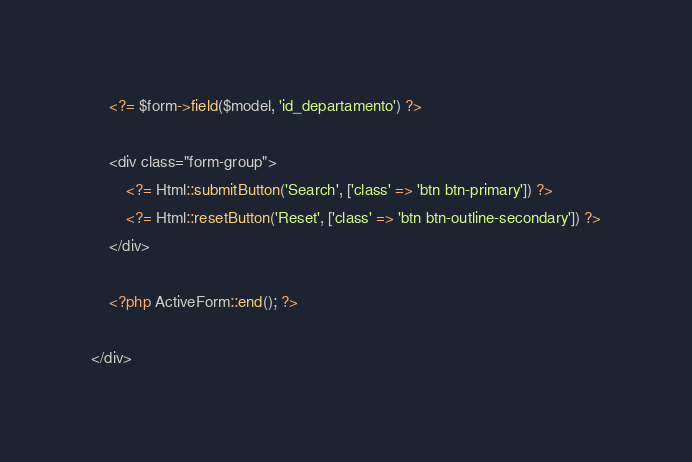<code> <loc_0><loc_0><loc_500><loc_500><_PHP_>    <?= $form->field($model, 'id_departamento') ?>

    <div class="form-group">
        <?= Html::submitButton('Search', ['class' => 'btn btn-primary']) ?>
        <?= Html::resetButton('Reset', ['class' => 'btn btn-outline-secondary']) ?>
    </div>

    <?php ActiveForm::end(); ?>

</div>
</code> 